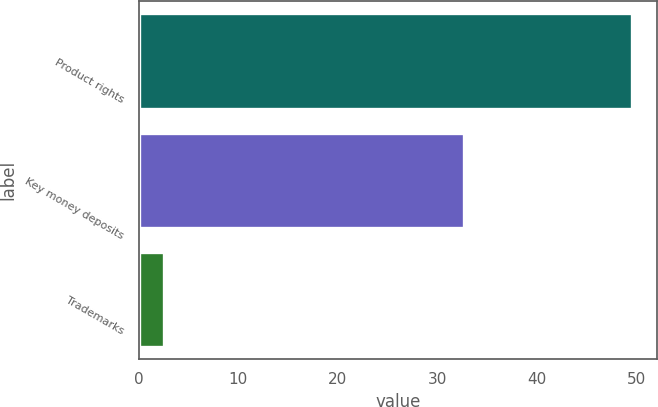<chart> <loc_0><loc_0><loc_500><loc_500><bar_chart><fcel>Product rights<fcel>Key money deposits<fcel>Trademarks<nl><fcel>49.6<fcel>32.7<fcel>2.5<nl></chart> 